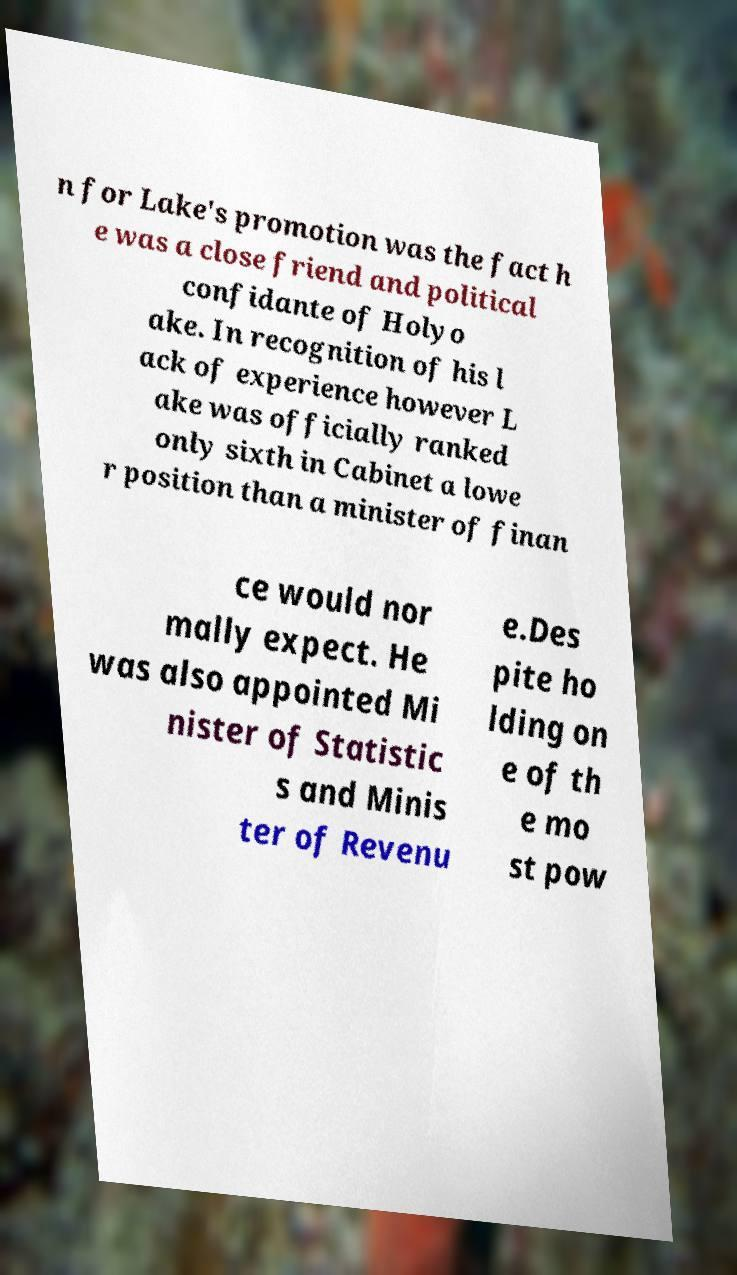Please identify and transcribe the text found in this image. n for Lake's promotion was the fact h e was a close friend and political confidante of Holyo ake. In recognition of his l ack of experience however L ake was officially ranked only sixth in Cabinet a lowe r position than a minister of finan ce would nor mally expect. He was also appointed Mi nister of Statistic s and Minis ter of Revenu e.Des pite ho lding on e of th e mo st pow 